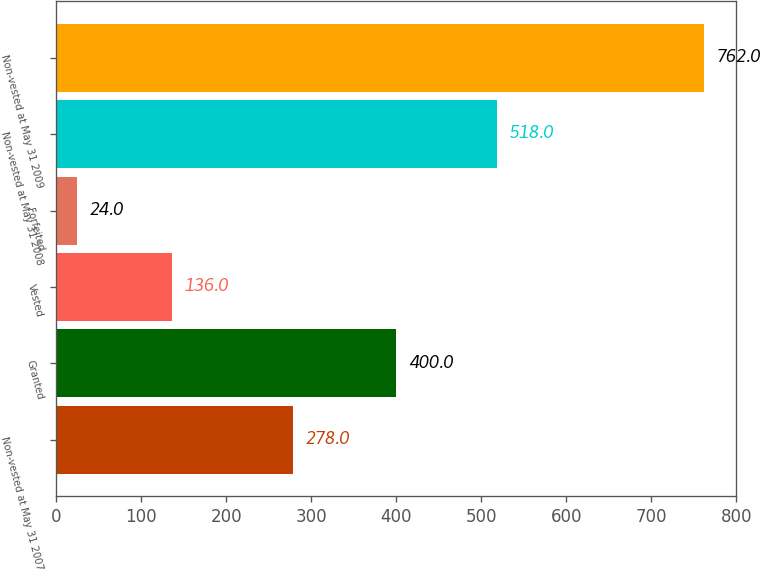Convert chart to OTSL. <chart><loc_0><loc_0><loc_500><loc_500><bar_chart><fcel>Non-vested at May 31 2007<fcel>Granted<fcel>Vested<fcel>Forfeited<fcel>Non-vested at May 31 2008<fcel>Non-vested at May 31 2009<nl><fcel>278<fcel>400<fcel>136<fcel>24<fcel>518<fcel>762<nl></chart> 